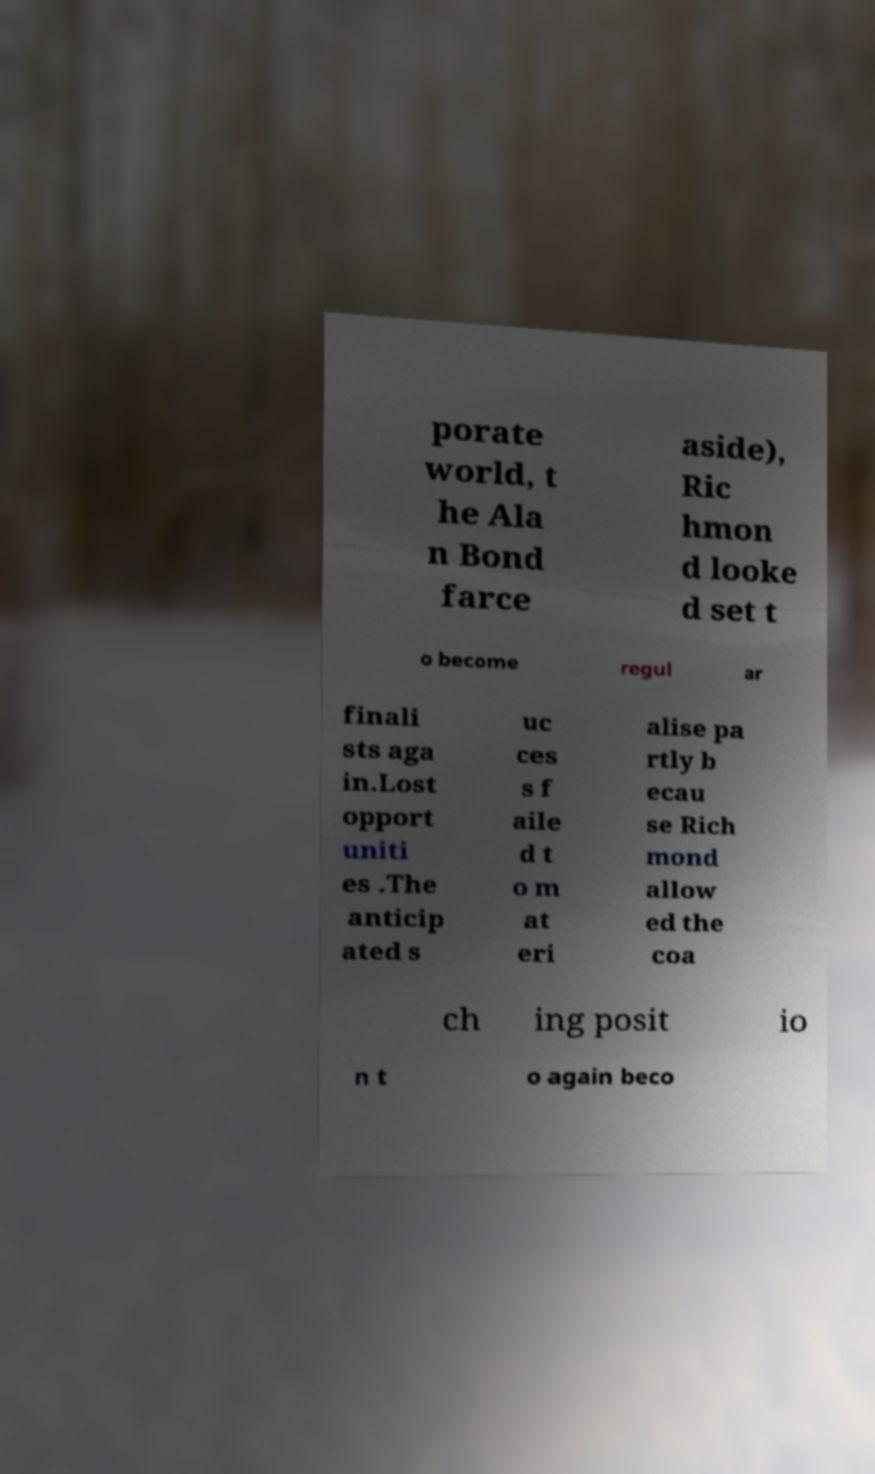Could you assist in decoding the text presented in this image and type it out clearly? porate world, t he Ala n Bond farce aside), Ric hmon d looke d set t o become regul ar finali sts aga in.Lost opport uniti es .The anticip ated s uc ces s f aile d t o m at eri alise pa rtly b ecau se Rich mond allow ed the coa ch ing posit io n t o again beco 